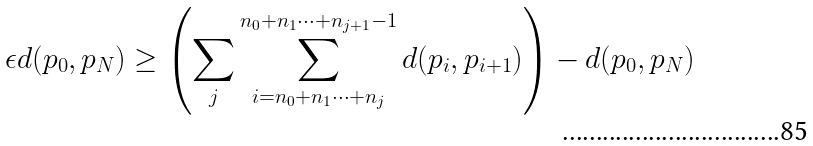Convert formula to latex. <formula><loc_0><loc_0><loc_500><loc_500>\epsilon d ( p _ { 0 } , p _ { N } ) \geq \left ( \sum _ { j } \sum _ { i = n _ { 0 } + n _ { 1 } \cdots + n _ { j } } ^ { n _ { 0 } + n _ { 1 } \cdots + n _ { j + 1 } - 1 } d ( p _ { i } , p _ { i + 1 } ) \right ) - d ( p _ { 0 } , p _ { N } )</formula> 